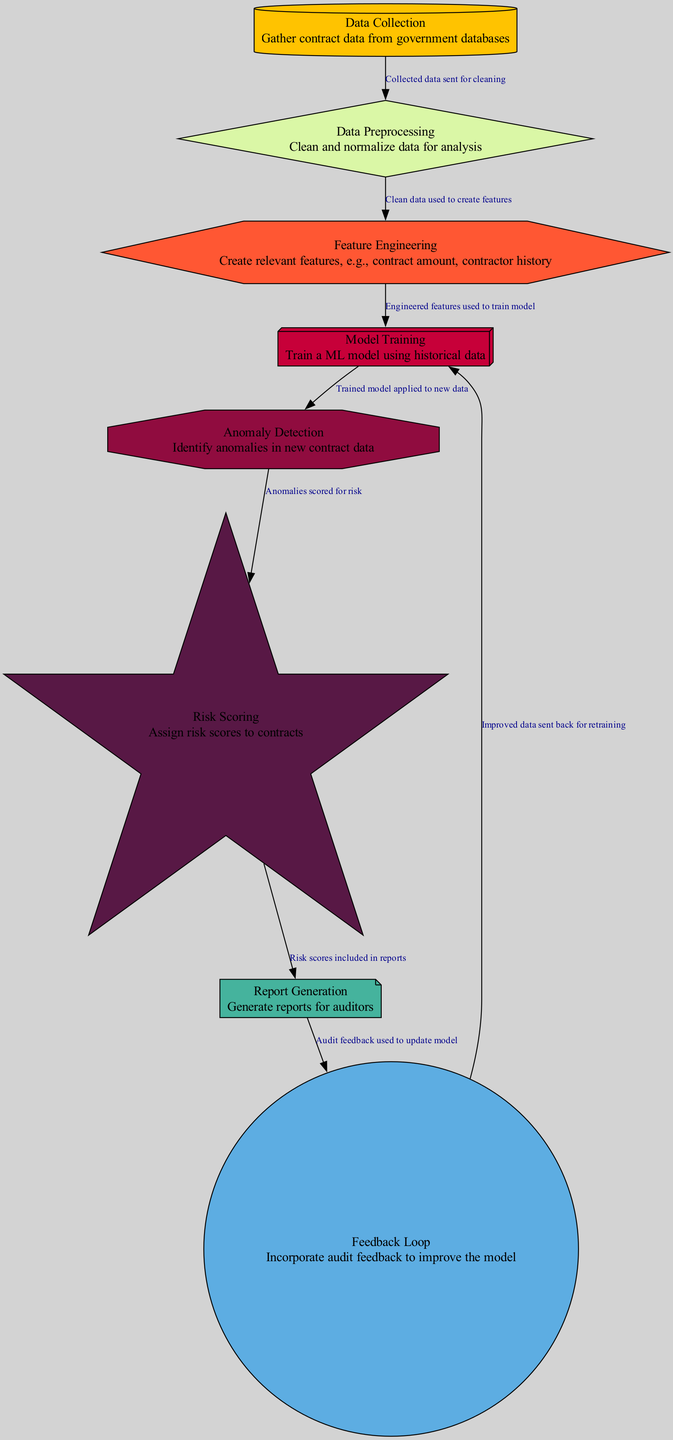What is the first step in the fraud detection process? The diagram shows that the first node is "Data Collection," indicating that this is the initial step where contract data is gathered from government databases.
Answer: Data Collection How many nodes are present in the diagram? By counting the nodes in the provided data, there are eight unique nodes indicating different steps in the fraud detection process.
Answer: Eight What is the shape of the "Model Training" node? The diagram specifies that "Model Training" is represented by a box3d shape, which is a distinct visual representation in the graph.
Answer: Box3d Which node generates reports for auditors? The node labeled "Report Generation" directly corresponds to the function of creating reports for auditors, as indicated in its description.
Answer: Report Generation What process follows "Feature Engineering"? The diagram clearly indicates that after "Feature Engineering," the next step is to "Model Training," linking the two processes directly.
Answer: Model Training In what stage are contracts assigned risk scores? According to the diagram, risk scores are assigned during the "Risk Scoring" stage, reflecting the importance of this step in evaluating potential fraud.
Answer: Risk Scoring What feedback is incorporated into the model? The diagram outlines that the "Feedback Loop" incorporates audit feedback to improve the model, emphasizing this interactive improvement process.
Answer: Audit feedback How are anomalies treated after detection? The edge description indicates that "Anomaly Detection" leads to "Risk Scoring," suggesting that after identifying anomalies, they are assessed for their potential risk.
Answer: Risk Scoring What type of diagram is depicted here? The diagram is identified as a "Machine Learning Diagram," specifically focusing on fraud detection in government contracts, as indicated in the introductory comment.
Answer: Machine Learning Diagram 